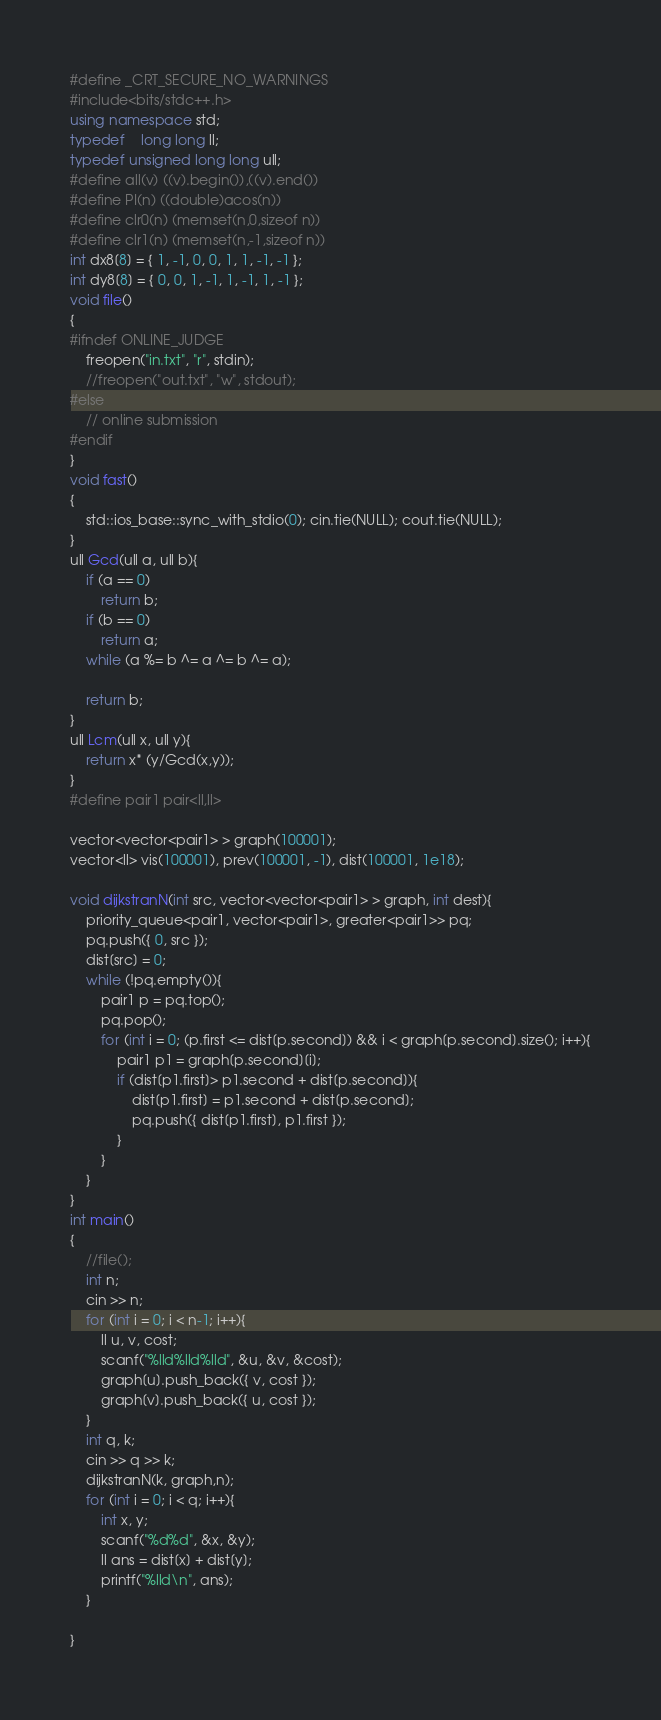<code> <loc_0><loc_0><loc_500><loc_500><_C++_>#define _CRT_SECURE_NO_WARNINGS
#include<bits/stdc++.h>
using namespace std;
typedef	long long ll;
typedef unsigned long long ull;
#define all(v) ((v).begin()),((v).end())
#define PI(n) ((double)acos(n))
#define clr0(n) (memset(n,0,sizeof n))
#define clr1(n) (memset(n,-1,sizeof n))
int dx8[8] = { 1, -1, 0, 0, 1, 1, -1, -1 };
int dy8[8] = { 0, 0, 1, -1, 1, -1, 1, -1 };
void file()
{
#ifndef ONLINE_JUDGE
	freopen("in.txt", "r", stdin);
	//freopen("out.txt", "w", stdout);
#else
	// online submission
#endif
}
void fast()
{
	std::ios_base::sync_with_stdio(0); cin.tie(NULL); cout.tie(NULL);
}
ull Gcd(ull a, ull b){
	if (a == 0)
		return b;
	if (b == 0)
		return a;
	while (a %= b ^= a ^= b ^= a);

	return b;
}
ull Lcm(ull x, ull y){
	return x* (y/Gcd(x,y));
}
#define pair1 pair<ll,ll>

vector<vector<pair1> > graph(100001);
vector<ll> vis(100001), prev(100001, -1), dist(100001, 1e18);

void dijkstranN(int src, vector<vector<pair1> > graph, int dest){
	priority_queue<pair1, vector<pair1>, greater<pair1>> pq;
	pq.push({ 0, src });
	dist[src] = 0;
	while (!pq.empty()){
		pair1 p = pq.top();
		pq.pop();
		for (int i = 0; (p.first <= dist[p.second]) && i < graph[p.second].size(); i++){
			pair1 p1 = graph[p.second][i];
			if (dist[p1.first]> p1.second + dist[p.second]){
				dist[p1.first] = p1.second + dist[p.second];
				pq.push({ dist[p1.first], p1.first });
			}
		}
	}
}
int main()
{
	//file();
	int n;
	cin >> n;
	for (int i = 0; i < n-1; i++){
		ll u, v, cost;
		scanf("%lld%lld%lld", &u, &v, &cost);
		graph[u].push_back({ v, cost });
		graph[v].push_back({ u, cost });
	}
	int q, k;
	cin >> q >> k;
	dijkstranN(k, graph,n);
	for (int i = 0; i < q; i++){
		int x, y;
		scanf("%d%d", &x, &y);
		ll ans = dist[x] + dist[y];
		printf("%lld\n", ans);
	}

}</code> 